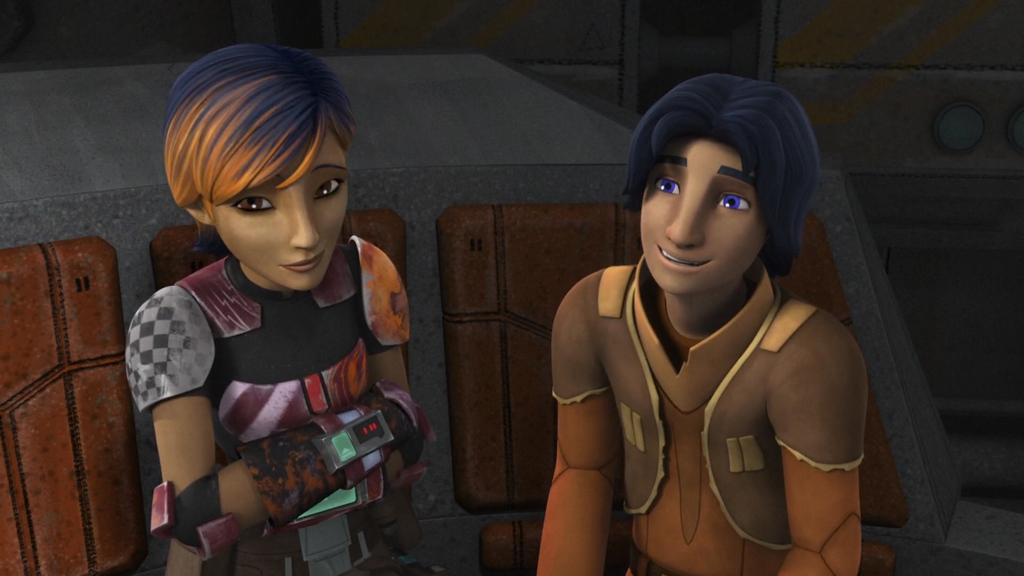What type of image is being described? The image is animated. What can be seen in the background of the animated image? There is a wall in the background of the image. Can you describe the characters in the image? There is a woman on the left side of the image and a man on the right side of the image. What type of sign is the man holding in the image? There is no sign present in the image; the man is not holding anything. 